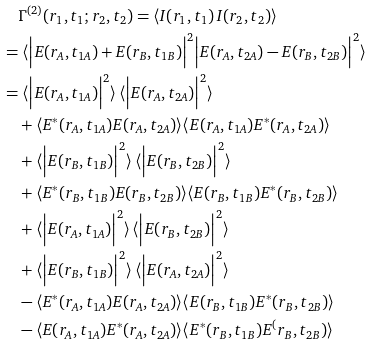<formula> <loc_0><loc_0><loc_500><loc_500>& \quad \Gamma ^ { ( 2 ) } ( r _ { 1 } , t _ { 1 } ; r _ { 2 } , t _ { 2 } ) = \langle I ( r _ { 1 } , t _ { 1 } ) \, I ( r _ { 2 } , t _ { 2 } ) \rangle \\ & = \langle \Big { | } E ( r _ { A } , t _ { 1 A } ) + E ( r _ { B } , t _ { 1 B } ) \Big { | } ^ { 2 } \Big { | } E ( r _ { A } , t _ { 2 A } ) - E ( r _ { B } , t _ { 2 B } ) \Big { | } ^ { 2 } \rangle \\ & = \langle \Big { | } E ( r _ { A } , t _ { 1 A } ) \Big { | } ^ { 2 } \rangle \, \langle \Big { | } E ( r _ { A } , t _ { 2 A } ) \Big { | } ^ { 2 } \rangle \\ & \quad + \langle E ^ { * } ( r _ { A } , t _ { 1 A } ) E ( r _ { A } , t _ { 2 A } ) \rangle \langle E ( r _ { A } , t _ { 1 A } ) E ^ { * } ( r _ { A } , t _ { 2 A } ) \rangle \\ & \quad + \langle \Big { | } E ( r _ { B } , t _ { 1 B } ) \Big { | } ^ { 2 } \rangle \, \langle \Big { | } E ( r _ { B } , t _ { 2 B } ) \Big { | } ^ { 2 } \rangle \\ & \quad + \langle E ^ { * } ( r _ { B } , t _ { 1 B } ) E ( r _ { B } , t _ { 2 B } ) \rangle \langle E ( r _ { B } , t _ { 1 B } ) E ^ { * } ( r _ { B } , t _ { 2 B } ) \rangle \\ & \quad + \langle \Big { | } E ( r _ { A } , t _ { 1 A } ) \Big { | } ^ { 2 } \rangle \, \langle \Big { | } E ( r _ { B } , t _ { 2 B } ) \Big { | } ^ { 2 } \rangle \\ & \quad + \langle \Big { | } E ( r _ { B } , t _ { 1 B } ) \Big { | } ^ { 2 } \rangle \, \langle \Big { | } E ( r _ { A } , t _ { 2 A } ) \Big { | } ^ { 2 } \rangle \\ & \quad - \langle E ^ { * } ( r _ { A } , t _ { 1 A } ) E ( r _ { A } , t _ { 2 A } ) \rangle \langle E ( r _ { B } , t _ { 1 B } ) E ^ { * } ( r _ { B } , t _ { 2 B } ) \rangle \\ & \quad - \langle E ( r _ { A } , t _ { 1 A } ) E ^ { * } ( r _ { A } , t _ { 2 A } ) \rangle \langle E ^ { * } ( r _ { B } , t _ { 1 B } ) E ^ { ( } r _ { B } , t _ { 2 B } ) \rangle</formula> 